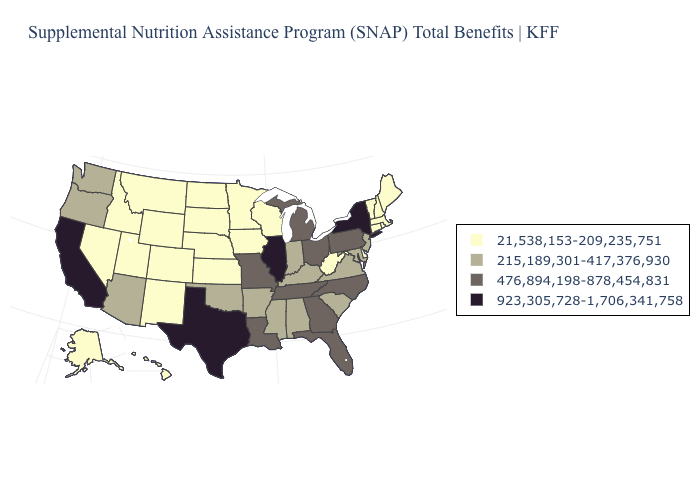What is the highest value in the MidWest ?
Keep it brief. 923,305,728-1,706,341,758. What is the value of South Carolina?
Give a very brief answer. 215,189,301-417,376,930. Does Pennsylvania have the lowest value in the Northeast?
Be succinct. No. Among the states that border Indiana , which have the highest value?
Short answer required. Illinois. What is the lowest value in states that border Mississippi?
Quick response, please. 215,189,301-417,376,930. Does Oregon have the highest value in the USA?
Give a very brief answer. No. What is the value of Wisconsin?
Short answer required. 21,538,153-209,235,751. Does Georgia have the highest value in the South?
Write a very short answer. No. Does Connecticut have a lower value than Virginia?
Quick response, please. Yes. Which states have the lowest value in the Northeast?
Give a very brief answer. Connecticut, Maine, Massachusetts, New Hampshire, Rhode Island, Vermont. What is the value of Missouri?
Write a very short answer. 476,894,198-878,454,831. Name the states that have a value in the range 215,189,301-417,376,930?
Answer briefly. Alabama, Arizona, Arkansas, Indiana, Kentucky, Maryland, Mississippi, New Jersey, Oklahoma, Oregon, South Carolina, Virginia, Washington. Does New Jersey have the lowest value in the Northeast?
Concise answer only. No. Name the states that have a value in the range 476,894,198-878,454,831?
Give a very brief answer. Florida, Georgia, Louisiana, Michigan, Missouri, North Carolina, Ohio, Pennsylvania, Tennessee. Does Kentucky have the same value as Mississippi?
Give a very brief answer. Yes. 